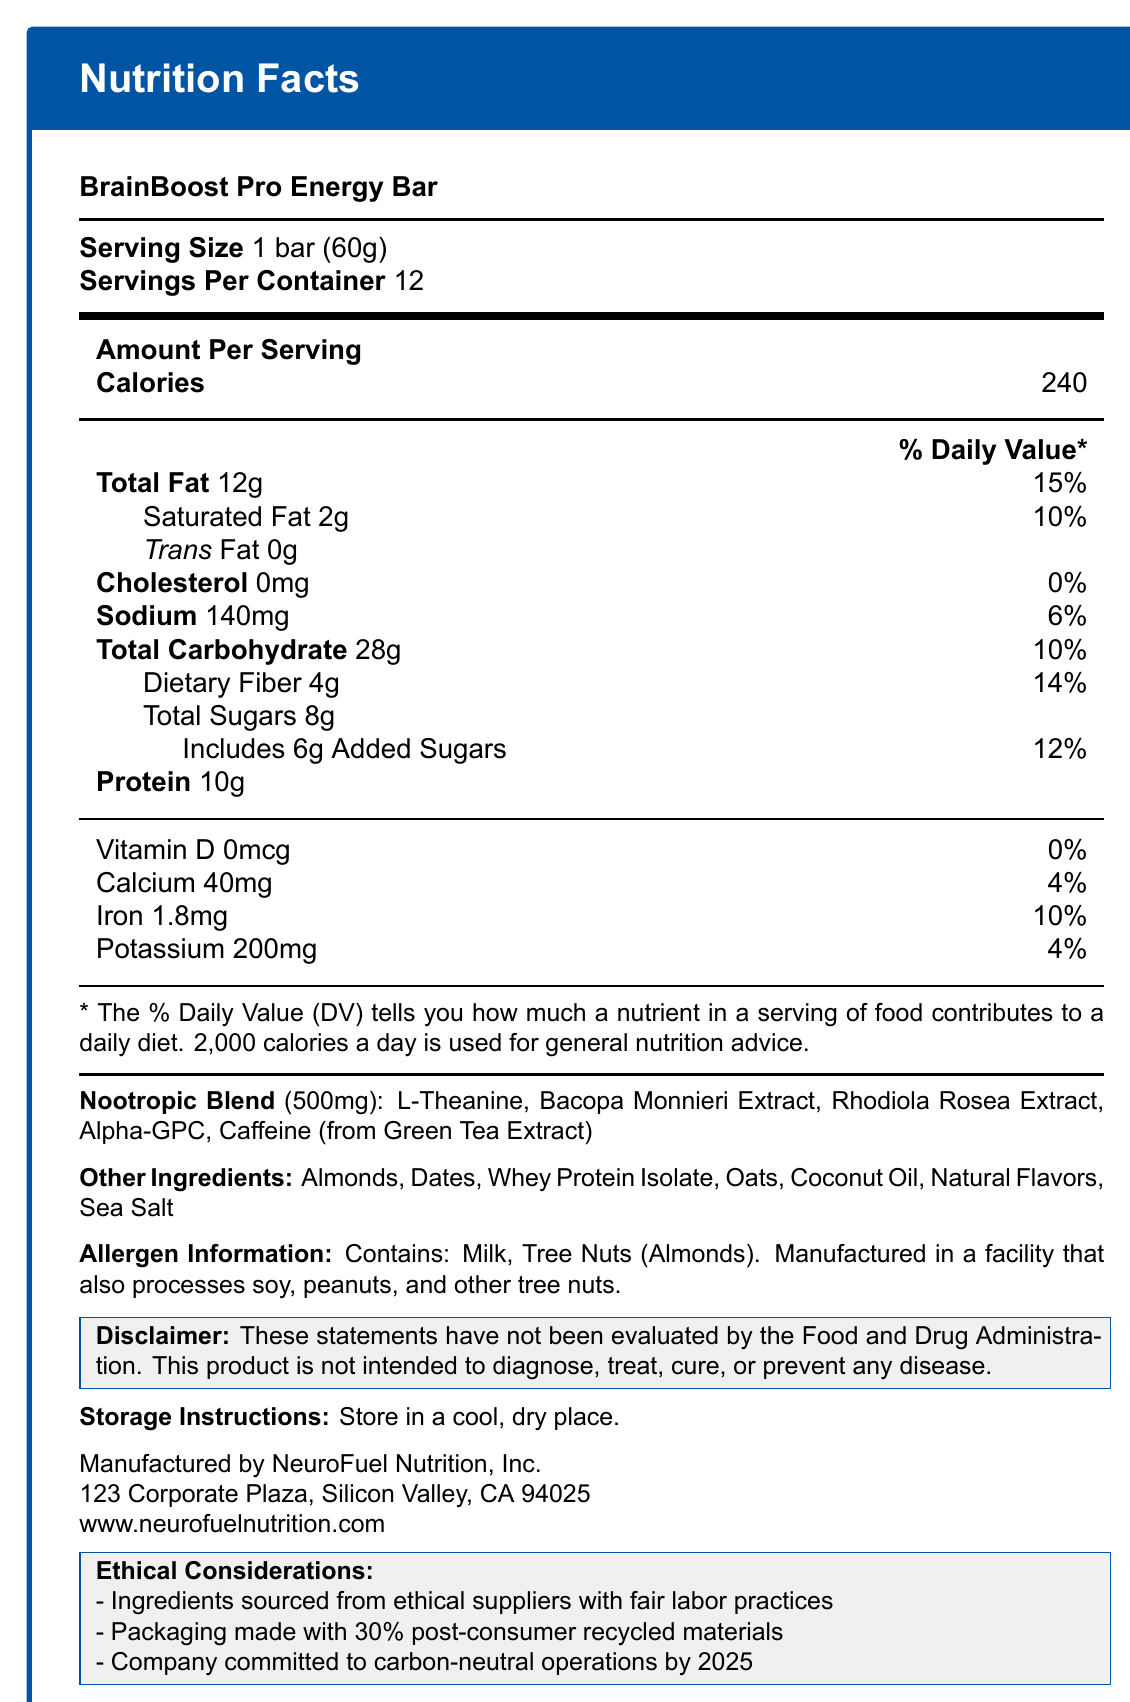what is the serving size of the BrainBoost Pro Energy Bar? The serving size is listed directly at the top of the Nutrition Facts section, indicated as "1 bar (60g)".
Answer: 1 bar (60g) how many calories are there per serving? The document clearly states that each serving contains 240 calories under the "Amount Per Serving" section.
Answer: 240 what is the percentage daily value of saturated fat? The percentage daily value for saturated fat is listed as 10% under the "Total Fat" section.
Answer: 10% List three ingredients in the nootropic blend. These ingredients are mentioned in the "Nootropic Blend" section of the document.
Answer: L-Theanine, Bacopa Monnieri Extract, Rhodiola Rosea Extract what is the added sugar content per serving? The amount of added sugars per serving is listed under the "Total Carbohydrate" section and also includes a daily value percentage of 12%.
Answer: 6g what is the total carbohydrate amount per serving? Total carbohydrates are listed as 28g per serving in the "Total Carbohydrate" section.
Answer: 28g Does the product contain any trans fat? The document states that the trans fat content is 0g in the "Total Fat" section.
Answer: No what are two allergens found in the energy bar? These allergens are listed in the "Allergen Information" section of the document.
Answer: Milk, Tree Nuts (Almonds) is the product gluten-free? The document does not mention any information regarding whether the product is gluten-free.
Answer: Cannot be determined which nootropic ingredient is sourced from Green Tea Extract? A. L-Theanine B. Bacopa Monnieri Extract C. Alpha-GPC D. Caffeine The document's "Nootropic Blend" section lists "Caffeine (from Green Tea Extract)".
Answer: D what is the daily value percentage of sodium for one serving? The sodium daily value percentage is listed as 6% under the "Sodium" section.
Answer: 6% what ethical considerations are noted in the document? A. No animal testing B. Ingredients sourced from ethical suppliers C. Packaging made with 100% recycled materials D. Company is committed to carbon-neutral operations by 2030 The ethical considerations sections note "Ingredients sourced from ethical suppliers with fair labor practices" and "Company committed to carbon-neutral operations by 2025", but there’s no mention of animal testing or 100% recycled materials for packaging.
Answer: B, D summarize the main information presented in the document. The summary captures the main nutritional data, special ingredients, allergen warnings, manufacturer details, and ethical commitments as presented in the document.
Answer: The BrainBoost Pro Energy Bar contains detailed nutritional information, including caloric content, fat, carbohydrate, and protein amounts, along with daily value percentages. It includes a unique nootropic blend aimed at enhancing cognitive performance, and contains allergens like milk and almonds. The product is manufactured by NeuroFuel Nutrition, Inc., which emphasizes ethical sourcing, partially recycled packaging, and a commitment to carbon-neutral operations by 2025. It includes a disclaimer that the product's statements have not been evaluated by the FDA. 